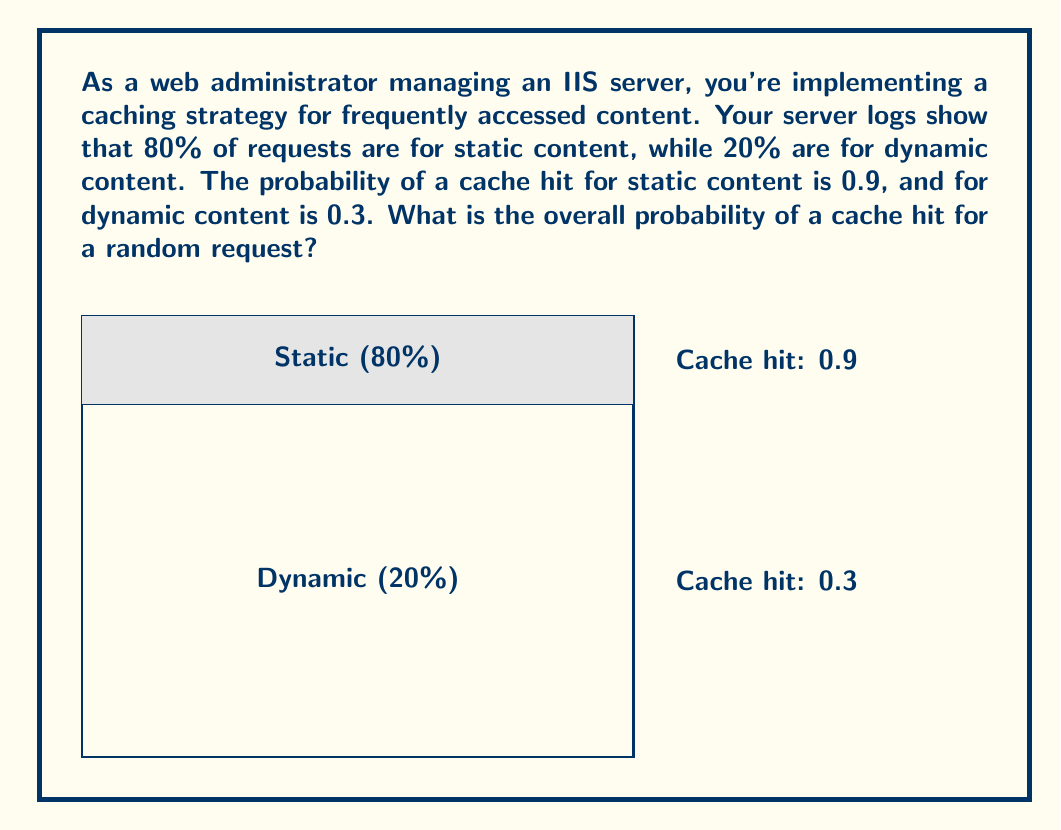Can you answer this question? Let's approach this step-by-step using probability theory:

1) Let's define our events:
   S: The request is for static content
   D: The request is for dynamic content
   H: A cache hit occurs

2) Given probabilities:
   P(S) = 0.8 (80% of requests are for static content)
   P(D) = 0.2 (20% of requests are for dynamic content)
   P(H|S) = 0.9 (probability of cache hit given static content)
   P(H|D) = 0.3 (probability of cache hit given dynamic content)

3) We want to find P(H), the overall probability of a cache hit.
   We can use the law of total probability:

   $$P(H) = P(H|S) \cdot P(S) + P(H|D) \cdot P(D)$$

4) Substituting the values:

   $$P(H) = 0.9 \cdot 0.8 + 0.3 \cdot 0.2$$

5) Calculating:

   $$P(H) = 0.72 + 0.06 = 0.78$$

Therefore, the overall probability of a cache hit for a random request is 0.78 or 78%.
Answer: 0.78 